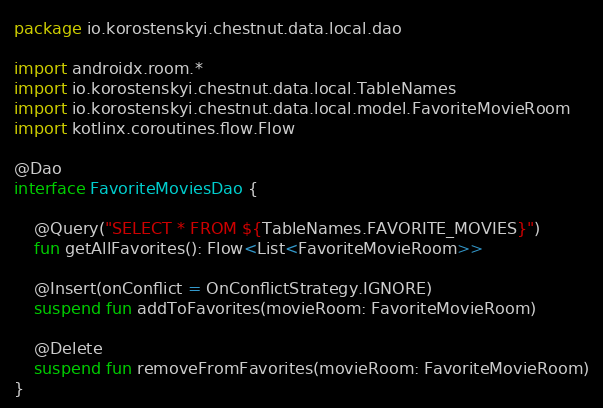Convert code to text. <code><loc_0><loc_0><loc_500><loc_500><_Kotlin_>package io.korostenskyi.chestnut.data.local.dao

import androidx.room.*
import io.korostenskyi.chestnut.data.local.TableNames
import io.korostenskyi.chestnut.data.local.model.FavoriteMovieRoom
import kotlinx.coroutines.flow.Flow

@Dao
interface FavoriteMoviesDao {

    @Query("SELECT * FROM ${TableNames.FAVORITE_MOVIES}")
    fun getAllFavorites(): Flow<List<FavoriteMovieRoom>>

    @Insert(onConflict = OnConflictStrategy.IGNORE)
    suspend fun addToFavorites(movieRoom: FavoriteMovieRoom)

    @Delete
    suspend fun removeFromFavorites(movieRoom: FavoriteMovieRoom)
}
</code> 